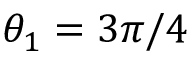<formula> <loc_0><loc_0><loc_500><loc_500>\theta _ { 1 } = 3 \pi / 4</formula> 